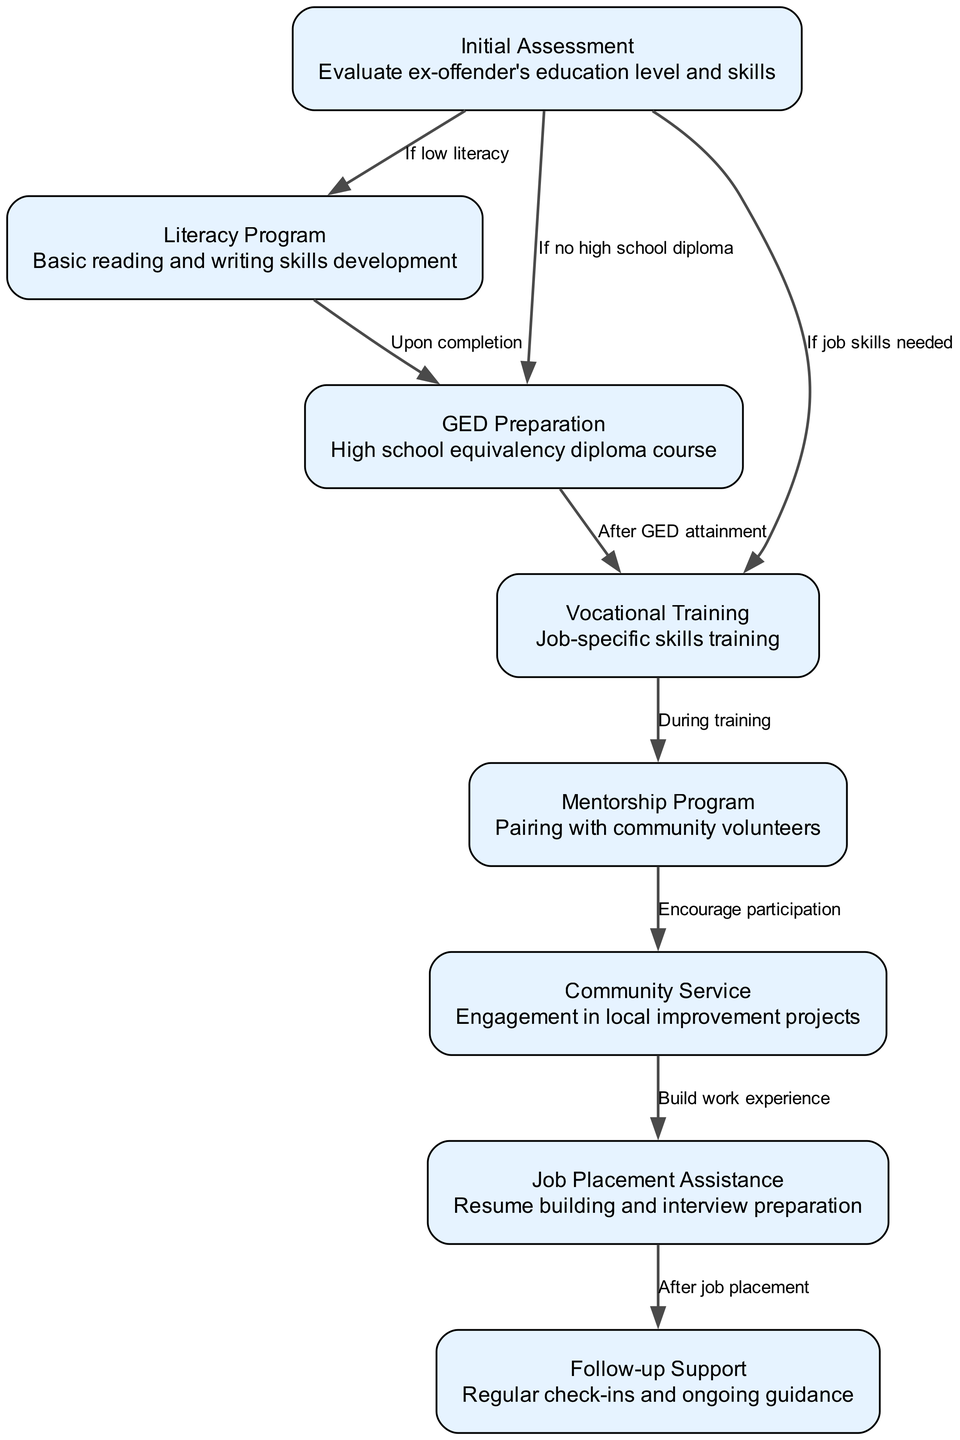What is the first step in the pathway? The first step in the pathway is the "Initial Assessment", where the ex-offender's education level and skills are evaluated.
Answer: Initial Assessment How many nodes are in this clinical pathway? By counting each unique step outlined in the pathway, there are a total of eight nodes representing different stages of integration into education initiatives.
Answer: 8 What is the output if the ex-offender is assessed with low literacy? If the ex-offender is assessed with low literacy, they will enter the "Literacy Program" for basic reading and writing skills development.
Answer: Literacy Program Which node follows after completing the Literacy Program? After completing the Literacy Program, the next step in the pathway is "GED Preparation", which involves taking a high school equivalency diploma course.
Answer: GED Preparation What is the purpose of the Mentorship Program in this pathway? The purpose of the Mentorship Program is to pair ex-offenders with community volunteers to provide guidance and support.
Answer: Pairing with community volunteers If an ex-offender completes their GED, what is the next step? Upon GED attainment, the next step is "Vocational Training", which provides job-specific skills training for the ex-offender.
Answer: Vocational Training What activity is encouraged during the Mentorship Program? The Mentorship Program encourages participation in "Community Service", where ex-offenders engage in local improvement projects.
Answer: Community Service What type of support is available after job placement? After job placement, "Follow-up Support" is available, which includes regular check-ins and ongoing guidance for the ex-offender.
Answer: Follow-up Support How do job skills influence the pathway? If job skills are needed, the ex-offender will transition to "Vocational Training" directly after the initial assessment to develop those necessary skills.
Answer: Vocational Training 